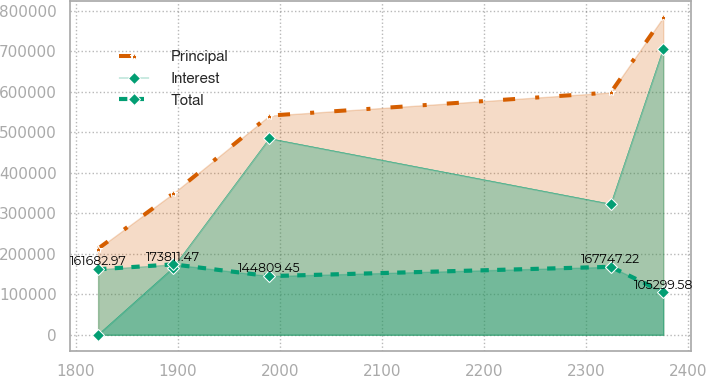Convert chart. <chart><loc_0><loc_0><loc_500><loc_500><line_chart><ecel><fcel>Principal<fcel>Interest<fcel>Total<nl><fcel>1821.9<fcel>212609<fcel>194.95<fcel>161683<nl><fcel>1895.47<fcel>348845<fcel>165392<fcel>173811<nl><fcel>1989.67<fcel>540866<fcel>484421<fcel>144809<nl><fcel>2324.16<fcel>597950<fcel>322602<fcel>167747<nl><fcel>2375.51<fcel>783450<fcel>705615<fcel>105300<nl></chart> 